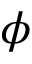Convert formula to latex. <formula><loc_0><loc_0><loc_500><loc_500>\phi</formula> 